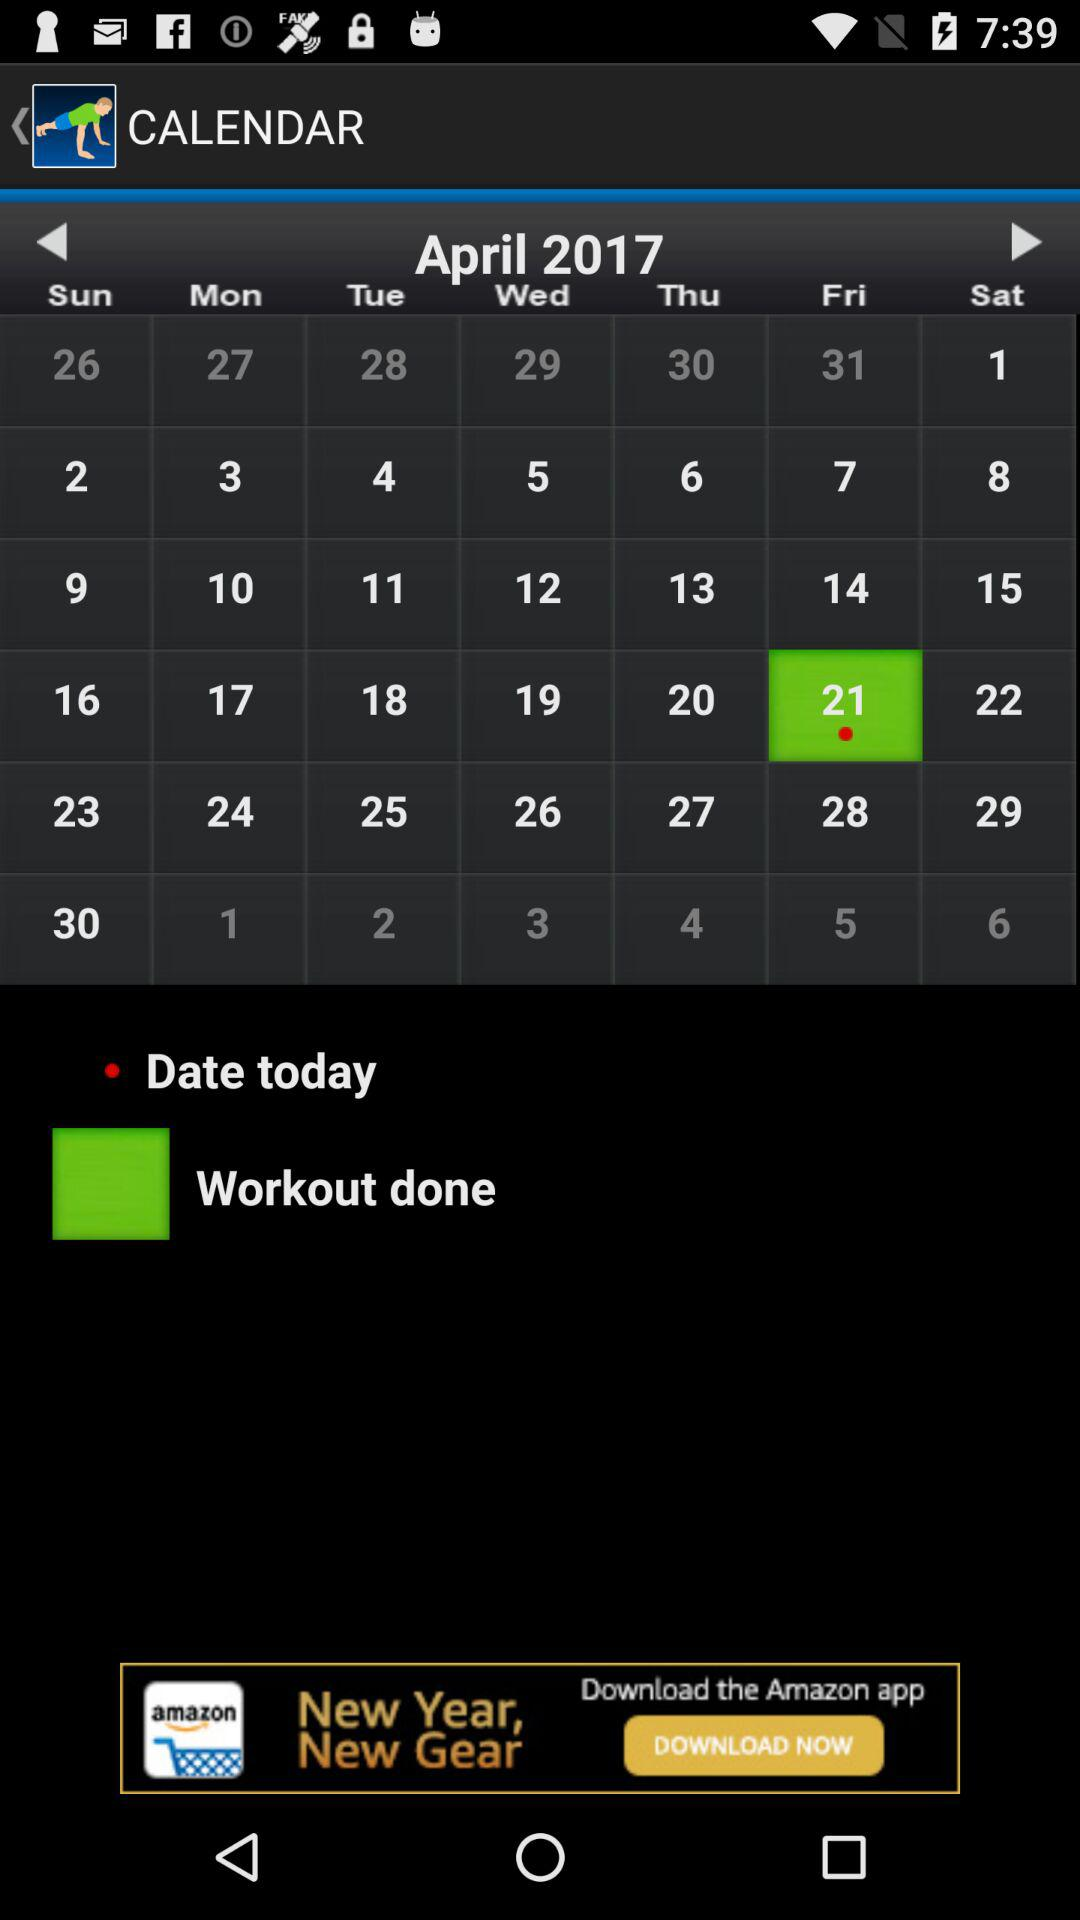What day is it on the selected date? On the selected date, it is a Friday. 